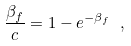<formula> <loc_0><loc_0><loc_500><loc_500>\frac { \beta _ { f } } c = 1 - e ^ { - \beta _ { f } } \ ,</formula> 